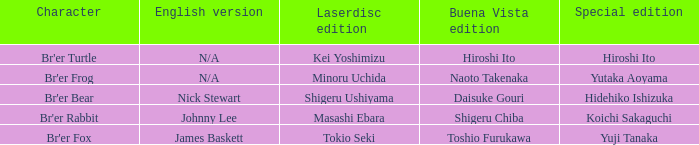What is the english version that is buena vista edition is daisuke gouri? Nick Stewart. 